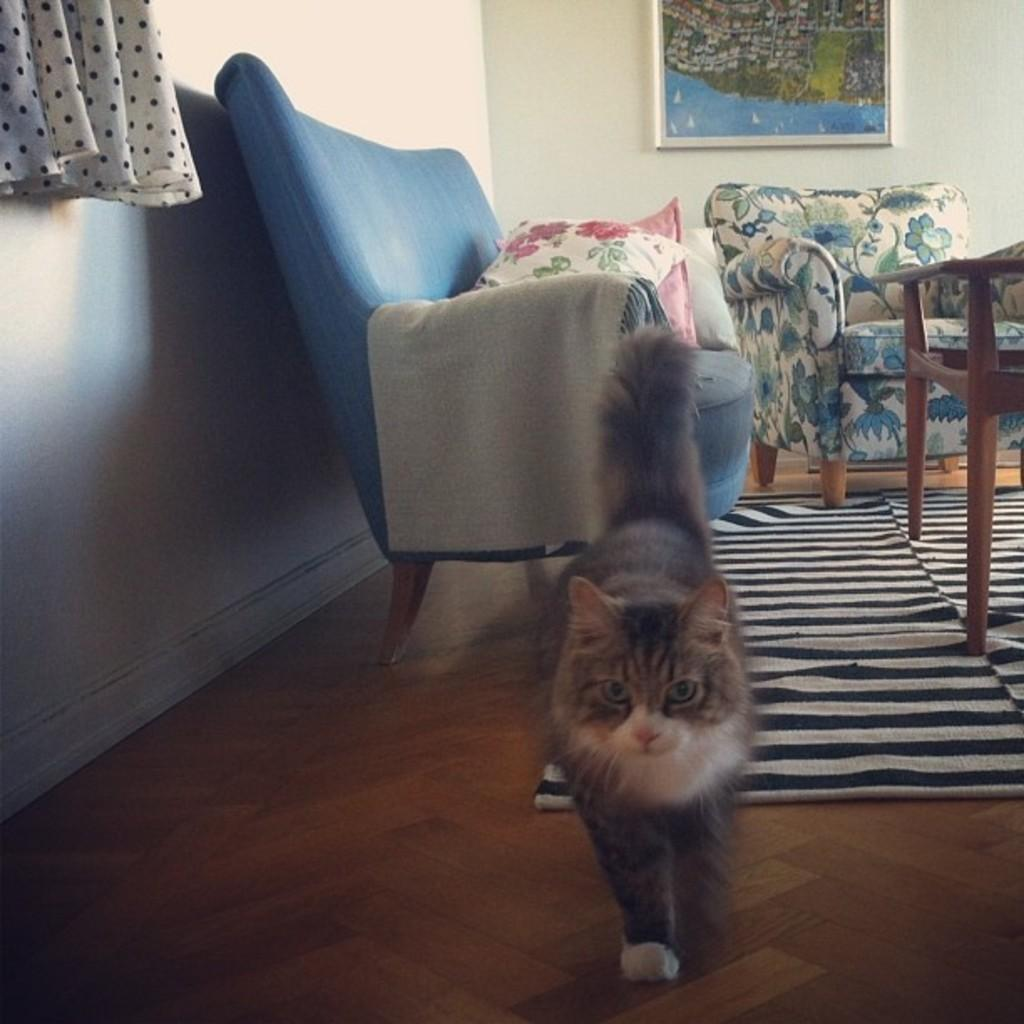What type of animal is in the image? There is a cat in the image. What type of furniture can be seen in the background? There is a couch with pillows, a sofa, and a table in the background. What is hanging on the wall in the background? There is a photo frame on the wall in the background. What type of window treatment is present in the image? There is a curtain in the image. What type of insurance policy is mentioned in the image? There is no mention of any insurance policy in the image. Can you see a kettle on the table in the image? There is no kettle visible on the table in the image. 